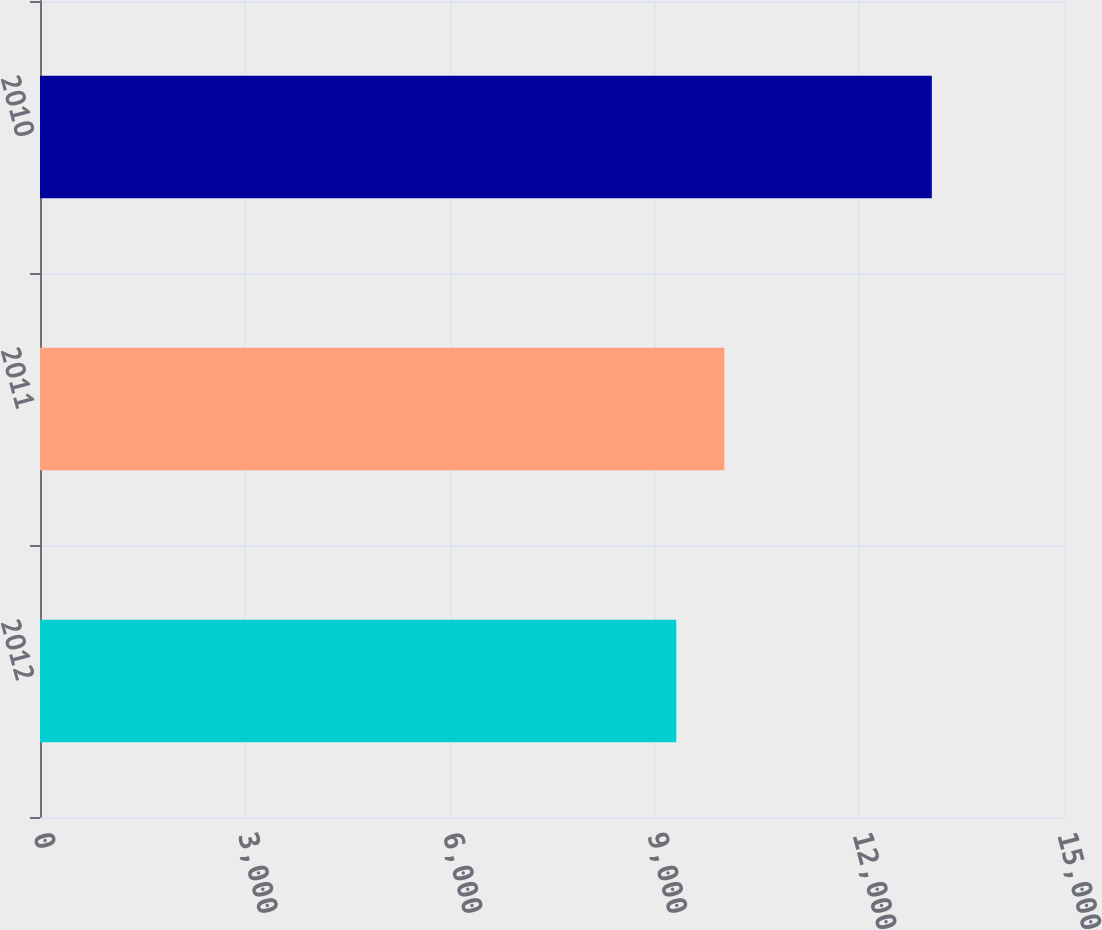Convert chart to OTSL. <chart><loc_0><loc_0><loc_500><loc_500><bar_chart><fcel>2012<fcel>2011<fcel>2010<nl><fcel>9320<fcel>10024<fcel>13064<nl></chart> 